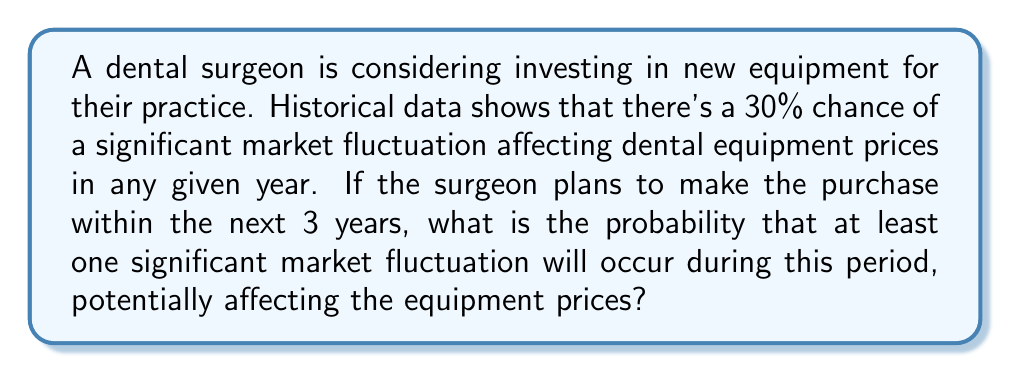Can you answer this question? To solve this problem, we'll use the concept of probability of complementary events. We'll calculate the probability of no significant market fluctuations occurring in 3 years and then subtract that from 1 to get the probability of at least one fluctuation.

Let's break it down step-by-step:

1. Probability of a significant market fluctuation in one year: $p = 0.30$
2. Probability of no significant market fluctuation in one year: $1 - p = 0.70$
3. Probability of no significant market fluctuations for 3 consecutive years:
   $$(0.70)^3 = 0.343$$

4. Probability of at least one significant market fluctuation in 3 years:
   $$1 - (0.70)^3 = 1 - 0.343 = 0.657$$

Therefore, the probability of at least one significant market fluctuation affecting dental equipment prices within the next 3 years is approximately 0.657 or 65.7%.

This calculation uses the concept of independent events and assumes that the probability of a market fluctuation remains constant each year.
Answer: The probability of at least one significant market fluctuation affecting dental equipment prices within the next 3 years is approximately 0.657 or 65.7%. 